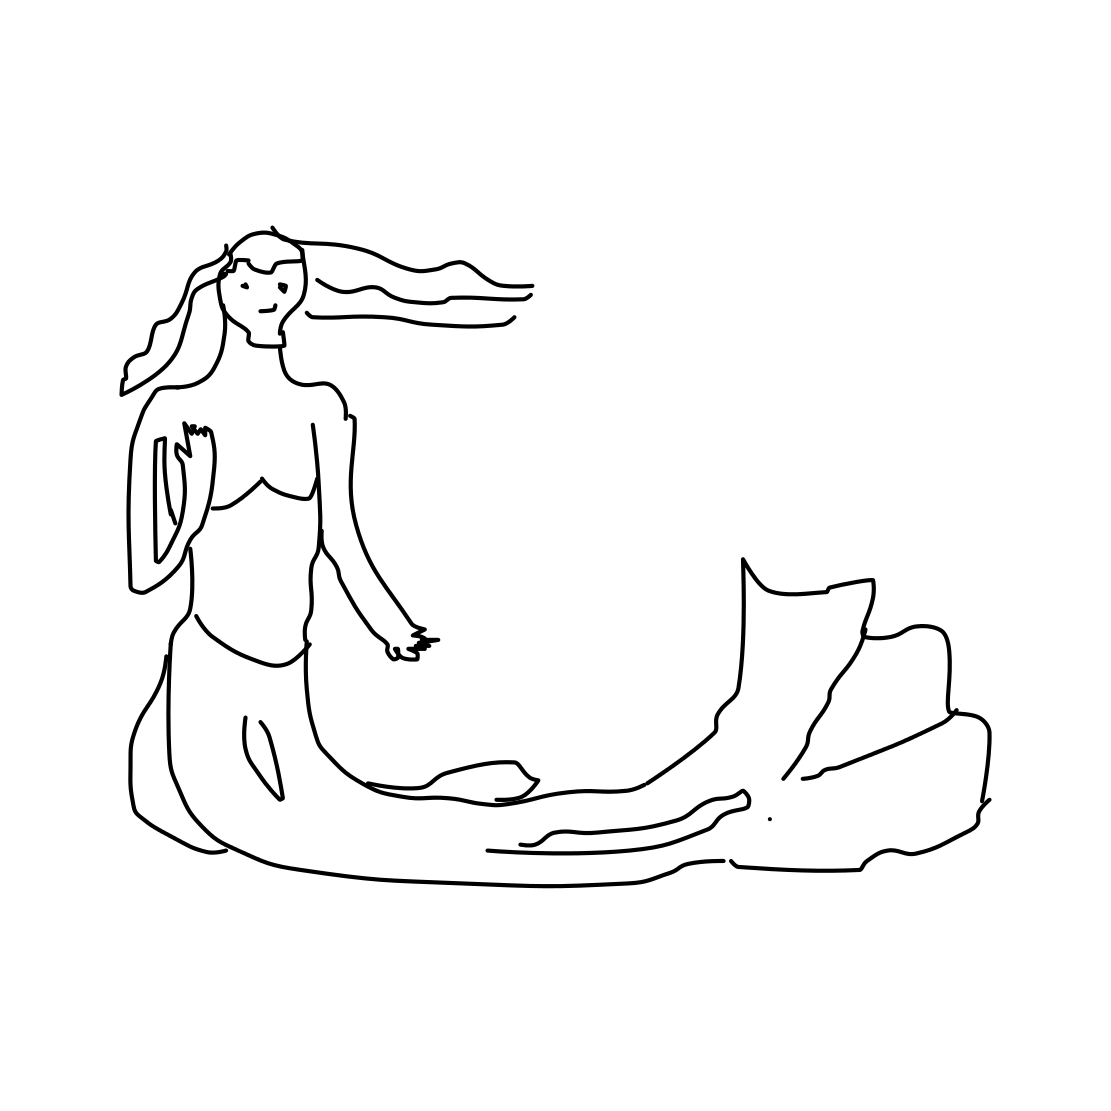Are there any other elements or creatures visible in the scene? No, there are no other creatures or significant elements visible besides the mermaid and the rock on which she is resting. Could you tell me more about the setting of this scene? The scene is quite minimalist, focusing solely on the mermaid. The background is plain, which suggests the image's focus is on the mystical and elegant nature of the mermaid herself. 